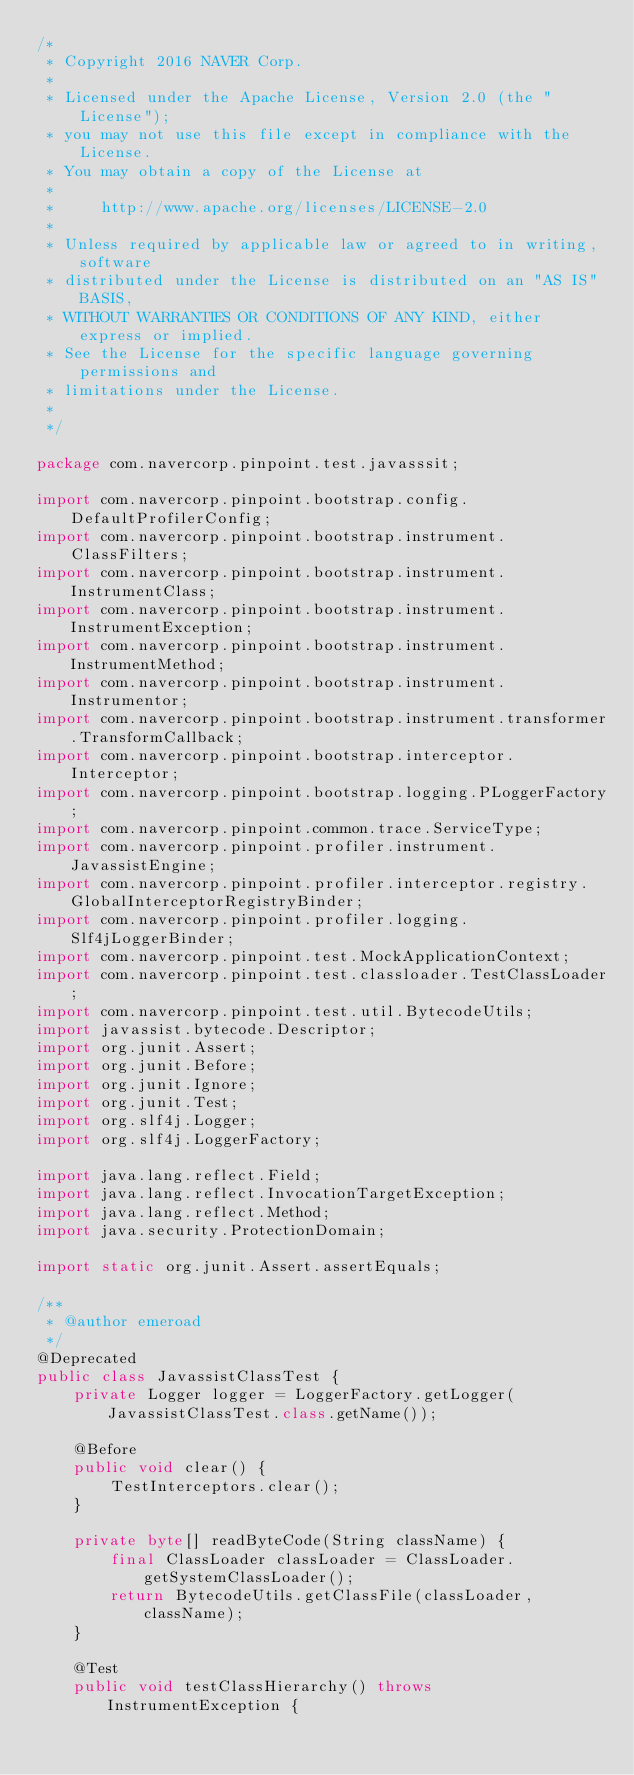Convert code to text. <code><loc_0><loc_0><loc_500><loc_500><_Java_>/*
 * Copyright 2016 NAVER Corp.
 *
 * Licensed under the Apache License, Version 2.0 (the "License");
 * you may not use this file except in compliance with the License.
 * You may obtain a copy of the License at
 *
 *     http://www.apache.org/licenses/LICENSE-2.0
 *
 * Unless required by applicable law or agreed to in writing, software
 * distributed under the License is distributed on an "AS IS" BASIS,
 * WITHOUT WARRANTIES OR CONDITIONS OF ANY KIND, either express or implied.
 * See the License for the specific language governing permissions and
 * limitations under the License.
 *
 */

package com.navercorp.pinpoint.test.javasssit;

import com.navercorp.pinpoint.bootstrap.config.DefaultProfilerConfig;
import com.navercorp.pinpoint.bootstrap.instrument.ClassFilters;
import com.navercorp.pinpoint.bootstrap.instrument.InstrumentClass;
import com.navercorp.pinpoint.bootstrap.instrument.InstrumentException;
import com.navercorp.pinpoint.bootstrap.instrument.InstrumentMethod;
import com.navercorp.pinpoint.bootstrap.instrument.Instrumentor;
import com.navercorp.pinpoint.bootstrap.instrument.transformer.TransformCallback;
import com.navercorp.pinpoint.bootstrap.interceptor.Interceptor;
import com.navercorp.pinpoint.bootstrap.logging.PLoggerFactory;
import com.navercorp.pinpoint.common.trace.ServiceType;
import com.navercorp.pinpoint.profiler.instrument.JavassistEngine;
import com.navercorp.pinpoint.profiler.interceptor.registry.GlobalInterceptorRegistryBinder;
import com.navercorp.pinpoint.profiler.logging.Slf4jLoggerBinder;
import com.navercorp.pinpoint.test.MockApplicationContext;
import com.navercorp.pinpoint.test.classloader.TestClassLoader;
import com.navercorp.pinpoint.test.util.BytecodeUtils;
import javassist.bytecode.Descriptor;
import org.junit.Assert;
import org.junit.Before;
import org.junit.Ignore;
import org.junit.Test;
import org.slf4j.Logger;
import org.slf4j.LoggerFactory;

import java.lang.reflect.Field;
import java.lang.reflect.InvocationTargetException;
import java.lang.reflect.Method;
import java.security.ProtectionDomain;

import static org.junit.Assert.assertEquals;

/**
 * @author emeroad
 */
@Deprecated
public class JavassistClassTest {
    private Logger logger = LoggerFactory.getLogger(JavassistClassTest.class.getName());

    @Before
    public void clear() {
        TestInterceptors.clear();
    }

    private byte[] readByteCode(String className) {
        final ClassLoader classLoader = ClassLoader.getSystemClassLoader();
        return BytecodeUtils.getClassFile(classLoader, className);
    }

    @Test
    public void testClassHierarchy() throws InstrumentException {</code> 